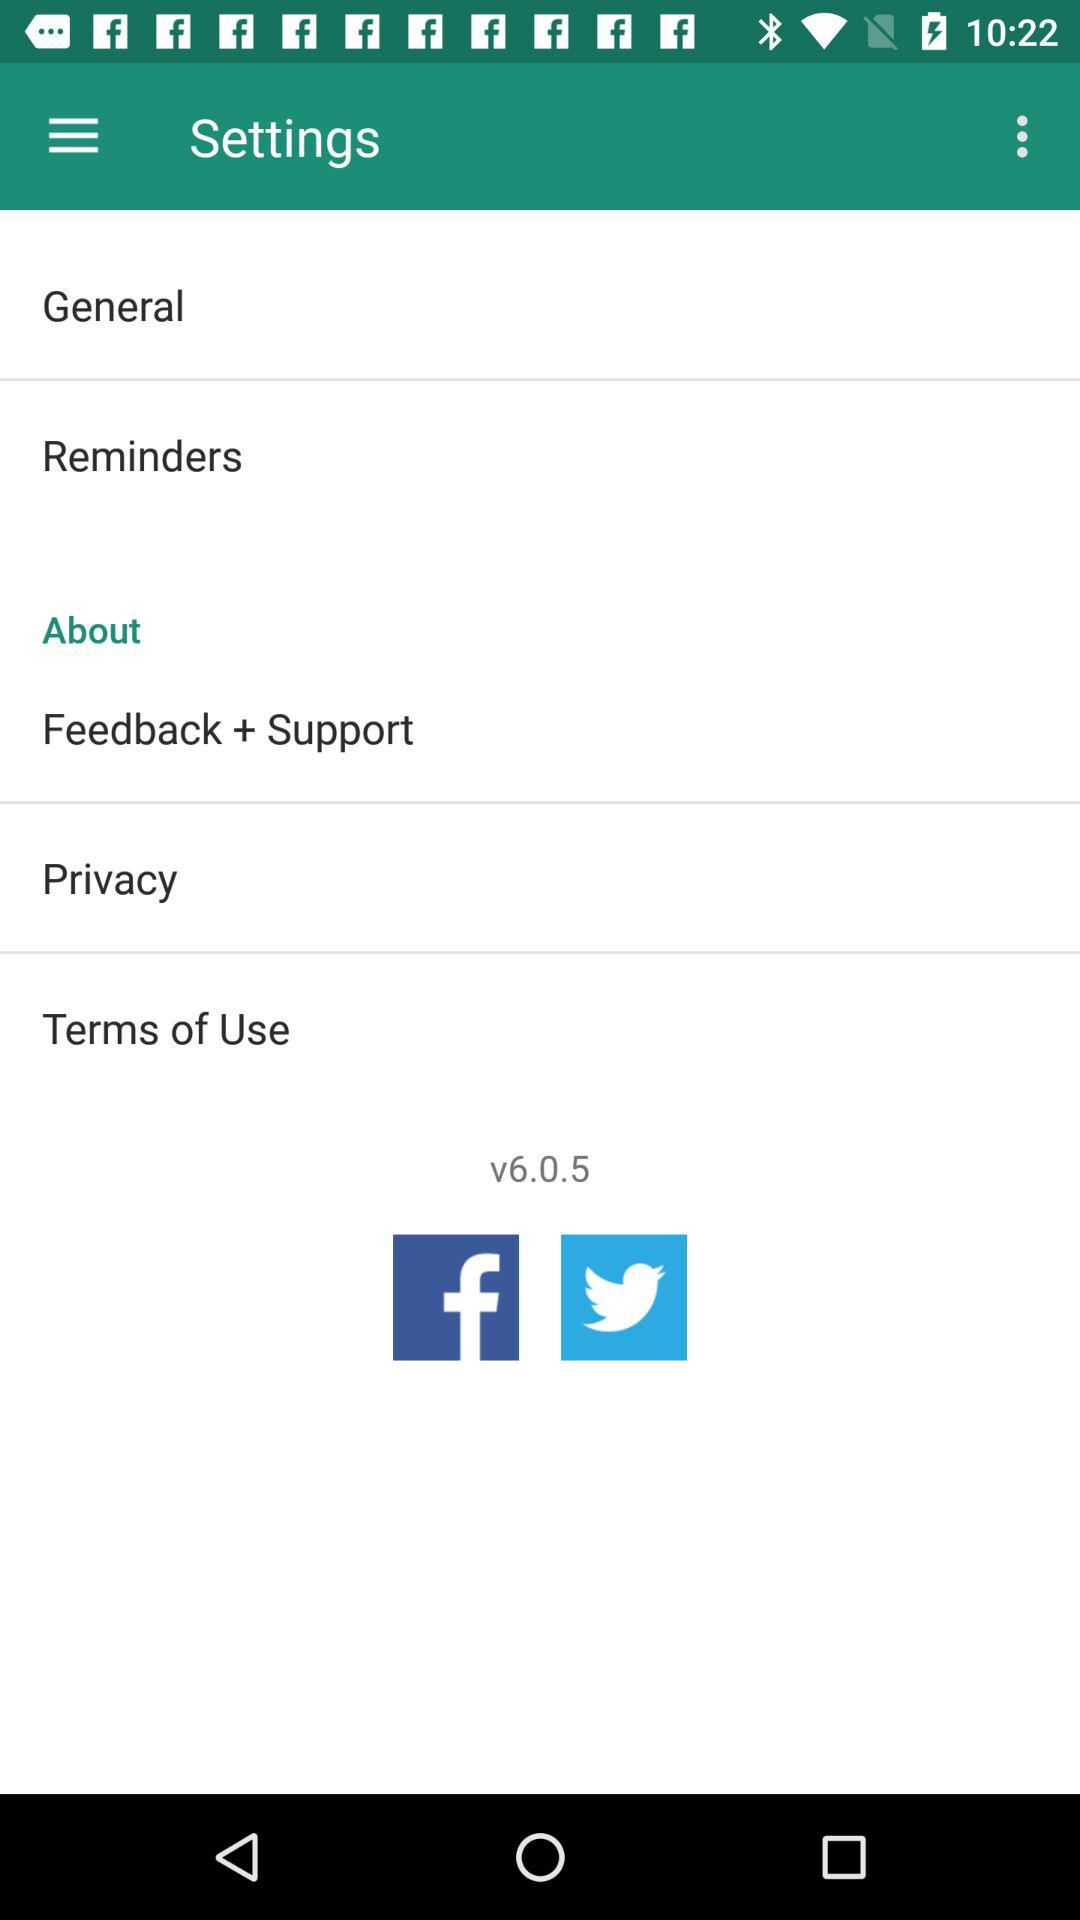Through which application can we share? You can share through "Facebook" and "Twitter". 